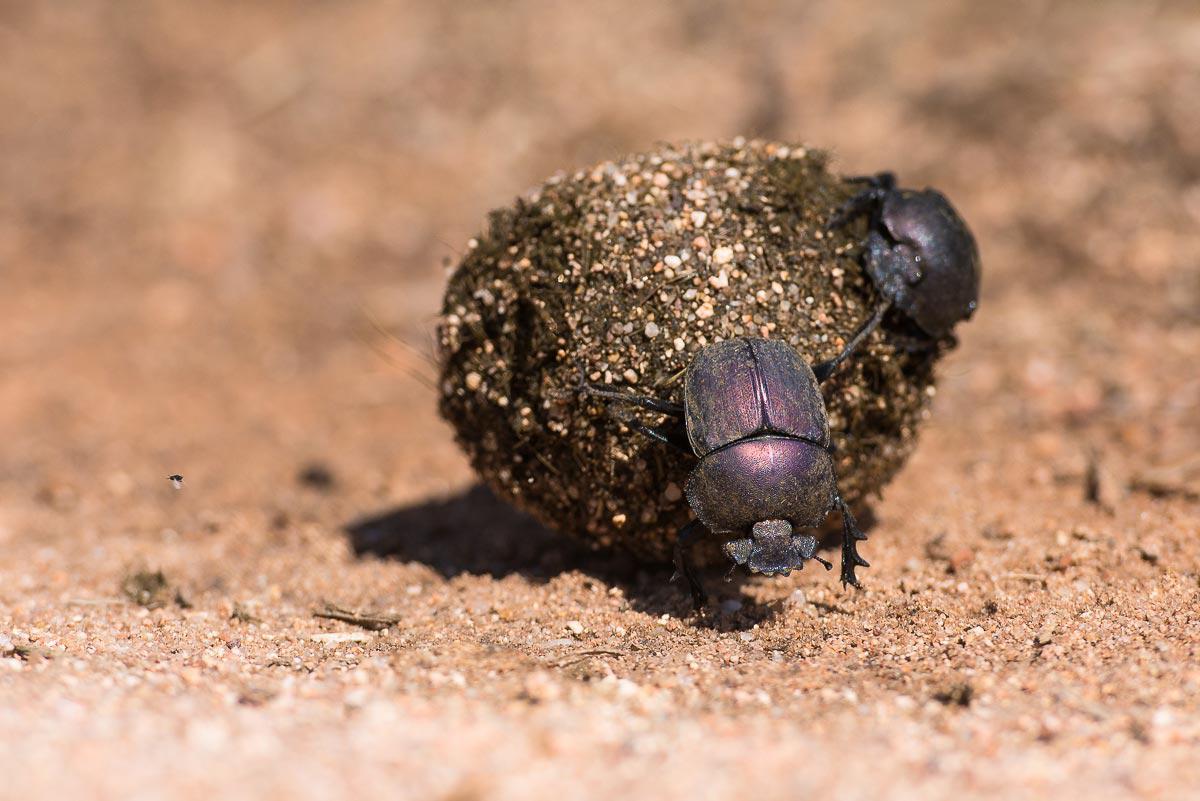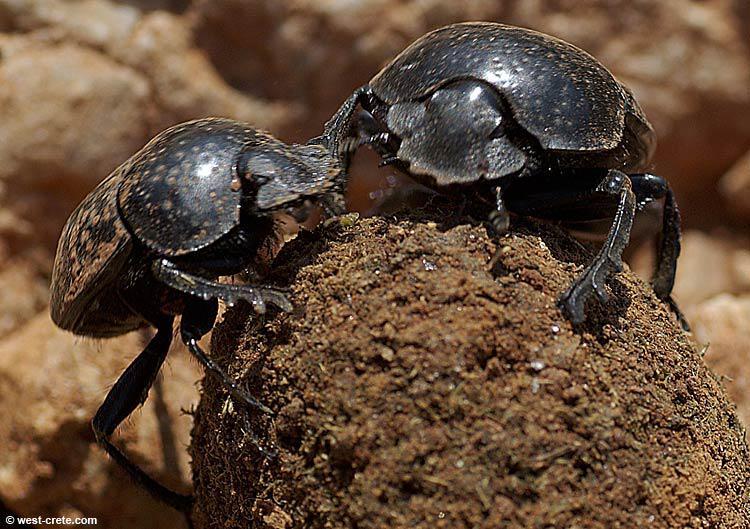The first image is the image on the left, the second image is the image on the right. Assess this claim about the two images: "Each image has at least 2 dung beetles interacting with a piece of dung.". Correct or not? Answer yes or no. Yes. 